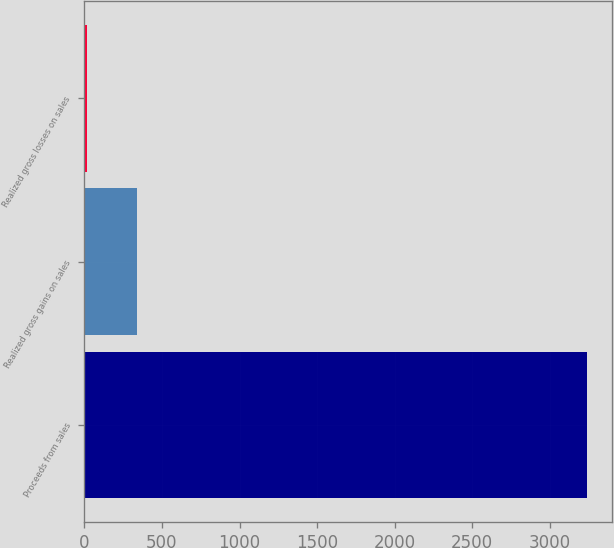Convert chart to OTSL. <chart><loc_0><loc_0><loc_500><loc_500><bar_chart><fcel>Proceeds from sales<fcel>Realized gross gains on sales<fcel>Realized gross losses on sales<nl><fcel>3240.5<fcel>337.19<fcel>14.6<nl></chart> 